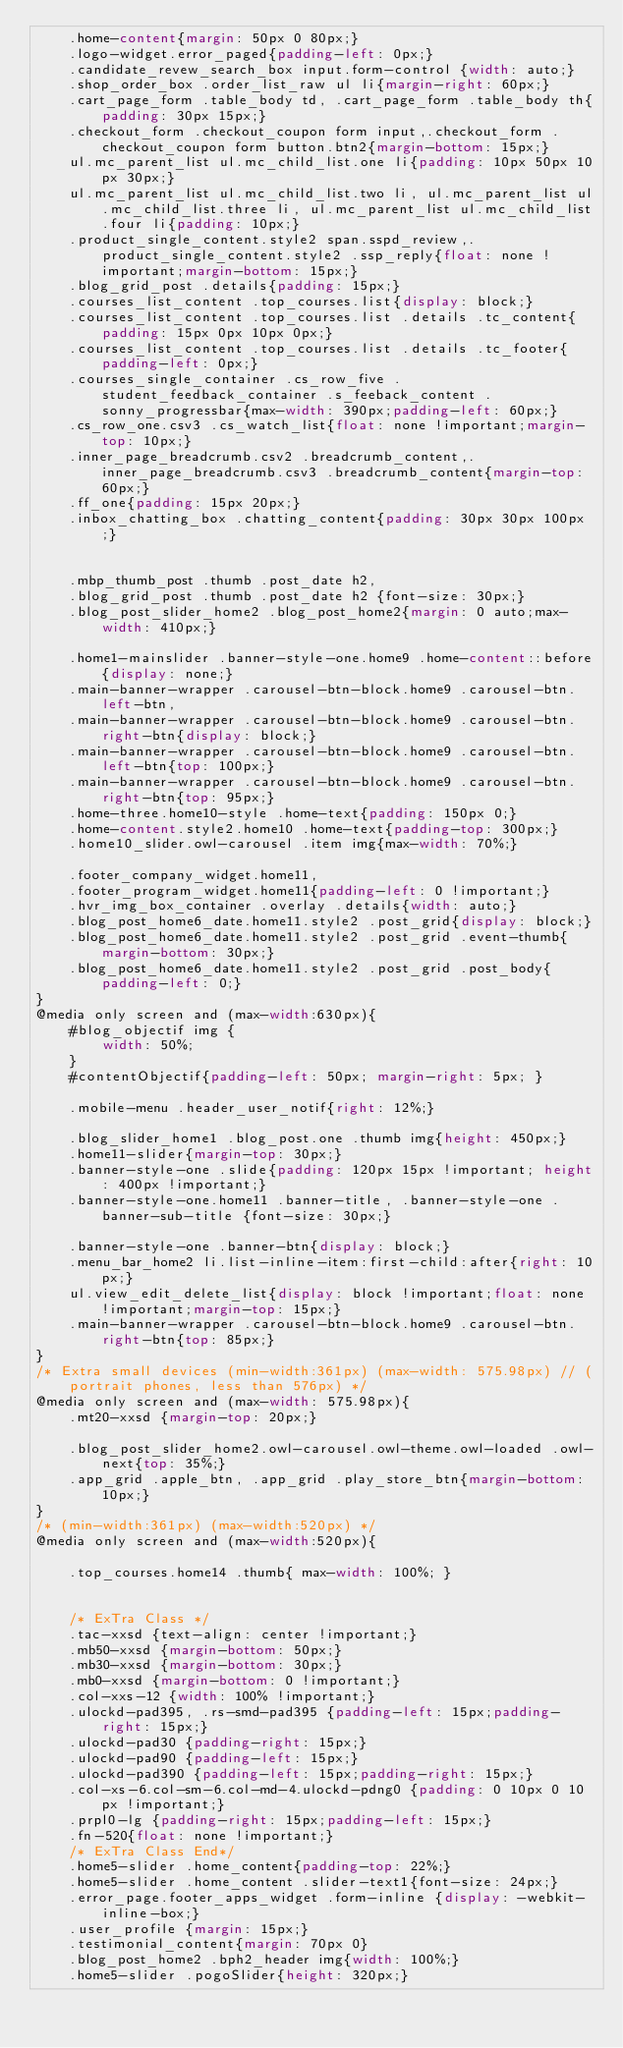Convert code to text. <code><loc_0><loc_0><loc_500><loc_500><_CSS_>	.home-content{margin: 50px 0 80px;}
	.logo-widget.error_paged{padding-left: 0px;}
	.candidate_revew_search_box input.form-control {width: auto;}
	.shop_order_box .order_list_raw ul li{margin-right: 60px;}
	.cart_page_form .table_body td, .cart_page_form .table_body th{padding: 30px 15px;}
	.checkout_form .checkout_coupon form input,.checkout_form .checkout_coupon form button.btn2{margin-bottom: 15px;}
	ul.mc_parent_list ul.mc_child_list.one li{padding: 10px 50px 10px 30px;}
	ul.mc_parent_list ul.mc_child_list.two li, ul.mc_parent_list ul.mc_child_list.three li, ul.mc_parent_list ul.mc_child_list.four li{padding: 10px;}
	.product_single_content.style2 span.sspd_review,.product_single_content.style2 .ssp_reply{float: none !important;margin-bottom: 15px;}
	.blog_grid_post .details{padding: 15px;}
	.courses_list_content .top_courses.list{display: block;}
	.courses_list_content .top_courses.list .details .tc_content{padding: 15px 0px 10px 0px;}
	.courses_list_content .top_courses.list .details .tc_footer{padding-left: 0px;}
	.courses_single_container .cs_row_five .student_feedback_container .s_feeback_content .sonny_progressbar{max-width: 390px;padding-left: 60px;}
	.cs_row_one.csv3 .cs_watch_list{float: none !important;margin-top: 10px;}
	.inner_page_breadcrumb.csv2 .breadcrumb_content,.inner_page_breadcrumb.csv3 .breadcrumb_content{margin-top: 60px;}
	.ff_one{padding: 15px 20px;}
	.inbox_chatting_box .chatting_content{padding: 30px 30px 100px;}


	.mbp_thumb_post .thumb .post_date h2,
	.blog_grid_post .thumb .post_date h2 {font-size: 30px;}
	.blog_post_slider_home2 .blog_post_home2{margin: 0 auto;max-width: 410px;}

	.home1-mainslider .banner-style-one.home9 .home-content::before{display: none;}
	.main-banner-wrapper .carousel-btn-block.home9 .carousel-btn.left-btn,
	.main-banner-wrapper .carousel-btn-block.home9 .carousel-btn.right-btn{display: block;}
	.main-banner-wrapper .carousel-btn-block.home9 .carousel-btn.left-btn{top: 100px;}
	.main-banner-wrapper .carousel-btn-block.home9 .carousel-btn.right-btn{top: 95px;}
	.home-three.home10-style .home-text{padding: 150px 0;}
	.home-content.style2.home10 .home-text{padding-top: 300px;}
	.home10_slider.owl-carousel .item img{max-width: 70%;}

	.footer_company_widget.home11,
	.footer_program_widget.home11{padding-left: 0 !important;}
	.hvr_img_box_container .overlay .details{width: auto;}
	.blog_post_home6_date.home11.style2 .post_grid{display: block;}
	.blog_post_home6_date.home11.style2 .post_grid .event-thumb{margin-bottom: 30px;}
	.blog_post_home6_date.home11.style2 .post_grid .post_body{padding-left: 0;}
}
@media only screen and (max-width:630px){
	#blog_objectif img {
		width: 50%;
	}
	#contentObjectif{padding-left: 50px; margin-right: 5px; }

	.mobile-menu .header_user_notif{right: 12%;}

	.blog_slider_home1 .blog_post.one .thumb img{height: 450px;}
	.home11-slider{margin-top: 30px;}
	.banner-style-one .slide{padding: 120px 15px !important; height: 400px !important;}
	.banner-style-one.home11 .banner-title, .banner-style-one .banner-sub-title {font-size: 30px;}

	.banner-style-one .banner-btn{display: block;}
	.menu_bar_home2 li.list-inline-item:first-child:after{right: 10px;}
	ul.view_edit_delete_list{display: block !important;float: none !important;margin-top: 15px;}
	.main-banner-wrapper .carousel-btn-block.home9 .carousel-btn.right-btn{top: 85px;}
}
/* Extra small devices (min-width:361px) (max-width: 575.98px) // (portrait phones, less than 576px) */
@media only screen and (max-width: 575.98px){
	.mt20-xxsd {margin-top: 20px;}
	
	.blog_post_slider_home2.owl-carousel.owl-theme.owl-loaded .owl-next{top: 35%;}
	.app_grid .apple_btn, .app_grid .play_store_btn{margin-bottom: 10px;}
}
/* (min-width:361px) (max-width:520px) */
@media only screen and (max-width:520px){

	.top_courses.home14 .thumb{ max-width: 100%; }

	
	/* ExTra Class */
	.tac-xxsd {text-align: center !important;}
	.mb50-xxsd {margin-bottom: 50px;}
	.mb30-xxsd {margin-bottom: 30px;}
	.mb0-xxsd {margin-bottom: 0 !important;}
	.col-xxs-12 {width: 100% !important;}
	.ulockd-pad395, .rs-smd-pad395 {padding-left: 15px;padding-right: 15px;}
	.ulockd-pad30 {padding-right: 15px;}
	.ulockd-pad90 {padding-left: 15px;}
	.ulockd-pad390 {padding-left: 15px;padding-right: 15px;}
	.col-xs-6.col-sm-6.col-md-4.ulockd-pdng0 {padding: 0 10px 0 10px !important;}
	.prpl0-lg {padding-right: 15px;padding-left: 15px;}
	.fn-520{float: none !important;}
	/* ExTra Class End*/
	.home5-slider .home_content{padding-top: 22%;}
	.home5-slider .home_content .slider-text1{font-size: 24px;}
	.error_page.footer_apps_widget .form-inline {display: -webkit-inline-box;}
	.user_profile {margin: 15px;}
	.testimonial_content{margin: 70px 0}
	.blog_post_home2 .bph2_header img{width: 100%;}
	.home5-slider .pogoSlider{height: 320px;}</code> 